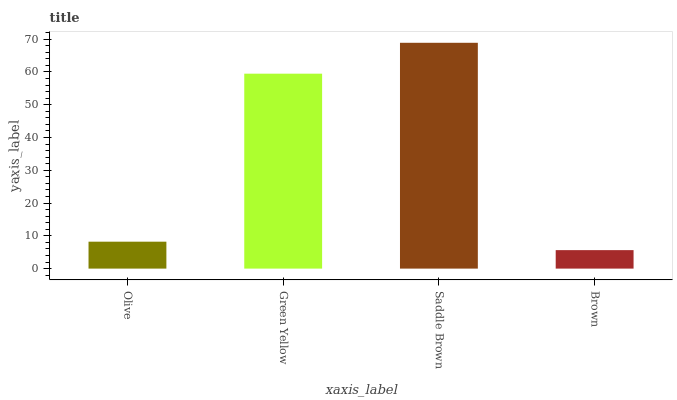Is Brown the minimum?
Answer yes or no. Yes. Is Saddle Brown the maximum?
Answer yes or no. Yes. Is Green Yellow the minimum?
Answer yes or no. No. Is Green Yellow the maximum?
Answer yes or no. No. Is Green Yellow greater than Olive?
Answer yes or no. Yes. Is Olive less than Green Yellow?
Answer yes or no. Yes. Is Olive greater than Green Yellow?
Answer yes or no. No. Is Green Yellow less than Olive?
Answer yes or no. No. Is Green Yellow the high median?
Answer yes or no. Yes. Is Olive the low median?
Answer yes or no. Yes. Is Olive the high median?
Answer yes or no. No. Is Green Yellow the low median?
Answer yes or no. No. 